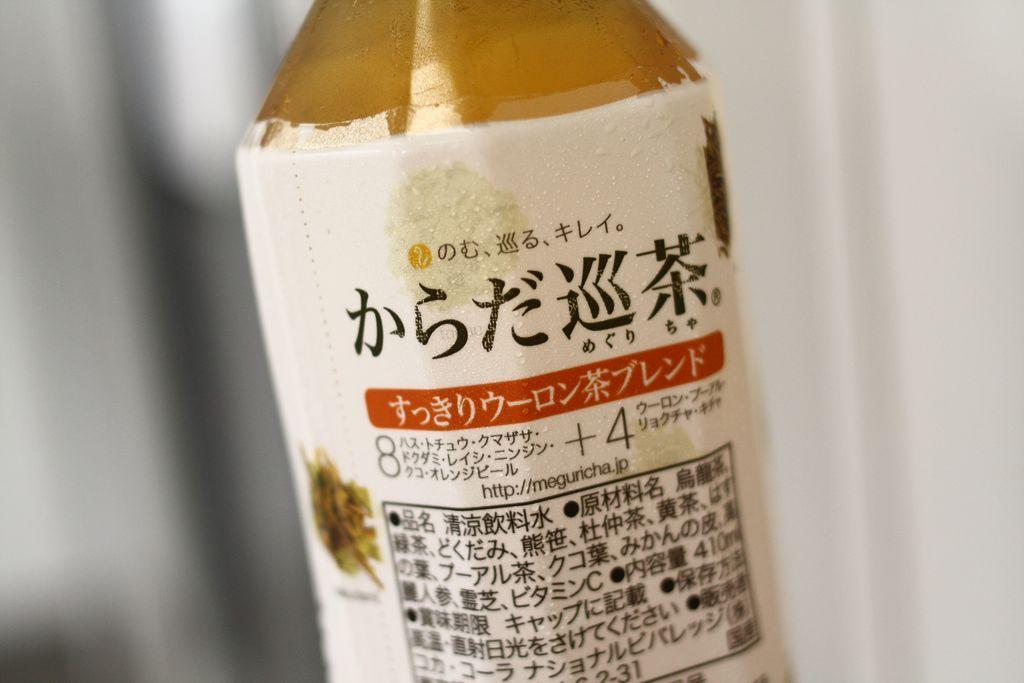Please provide a concise description of this image. In this image there is a bottle on that bottle there is some written text. 